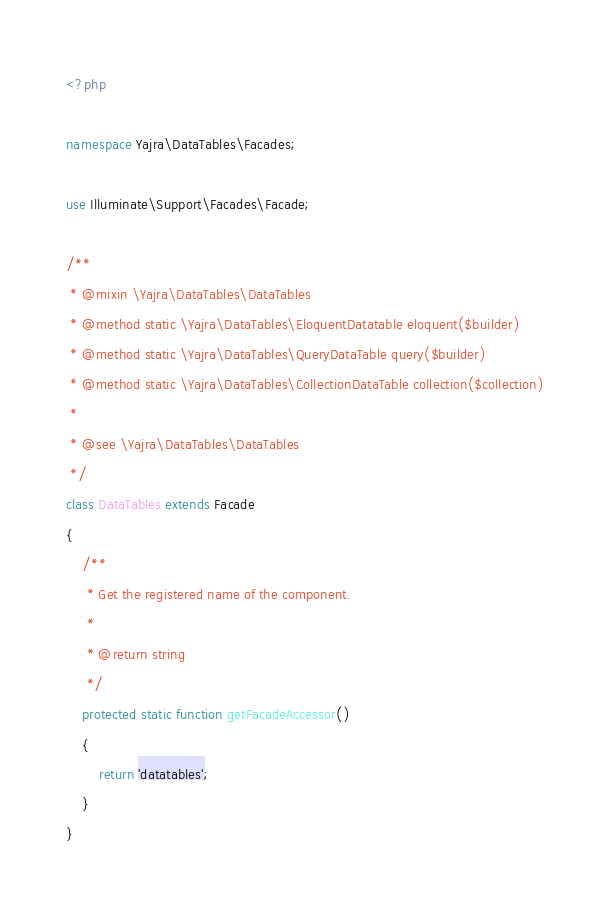Convert code to text. <code><loc_0><loc_0><loc_500><loc_500><_PHP_><?php

namespace Yajra\DataTables\Facades;

use Illuminate\Support\Facades\Facade;

/**
 * @mixin \Yajra\DataTables\DataTables
 * @method static \Yajra\DataTables\EloquentDatatable eloquent($builder)
 * @method static \Yajra\DataTables\QueryDataTable query($builder)
 * @method static \Yajra\DataTables\CollectionDataTable collection($collection)
 *
 * @see \Yajra\DataTables\DataTables
 */
class DataTables extends Facade
{
    /**
     * Get the registered name of the component.
     *
     * @return string
     */
    protected static function getFacadeAccessor()
    {
        return 'datatables';
    }
}
</code> 